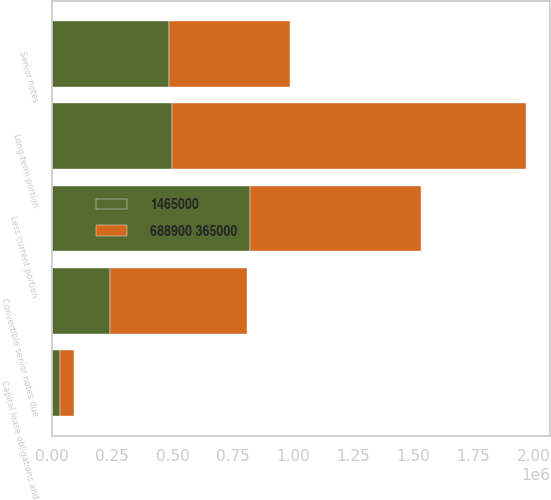<chart> <loc_0><loc_0><loc_500><loc_500><stacked_bar_chart><ecel><fcel>Senior notes<fcel>Convertible senior notes due<fcel>Capital lease obligations and<fcel>Less current portion<fcel>Long-term portion<nl><fcel>1465000<fcel>487000<fcel>238869<fcel>33425<fcel>824463<fcel>500000<nl><fcel>688900 365000<fcel>500000<fcel>569100<fcel>57175<fcel>709449<fcel>1.47073e+06<nl></chart> 